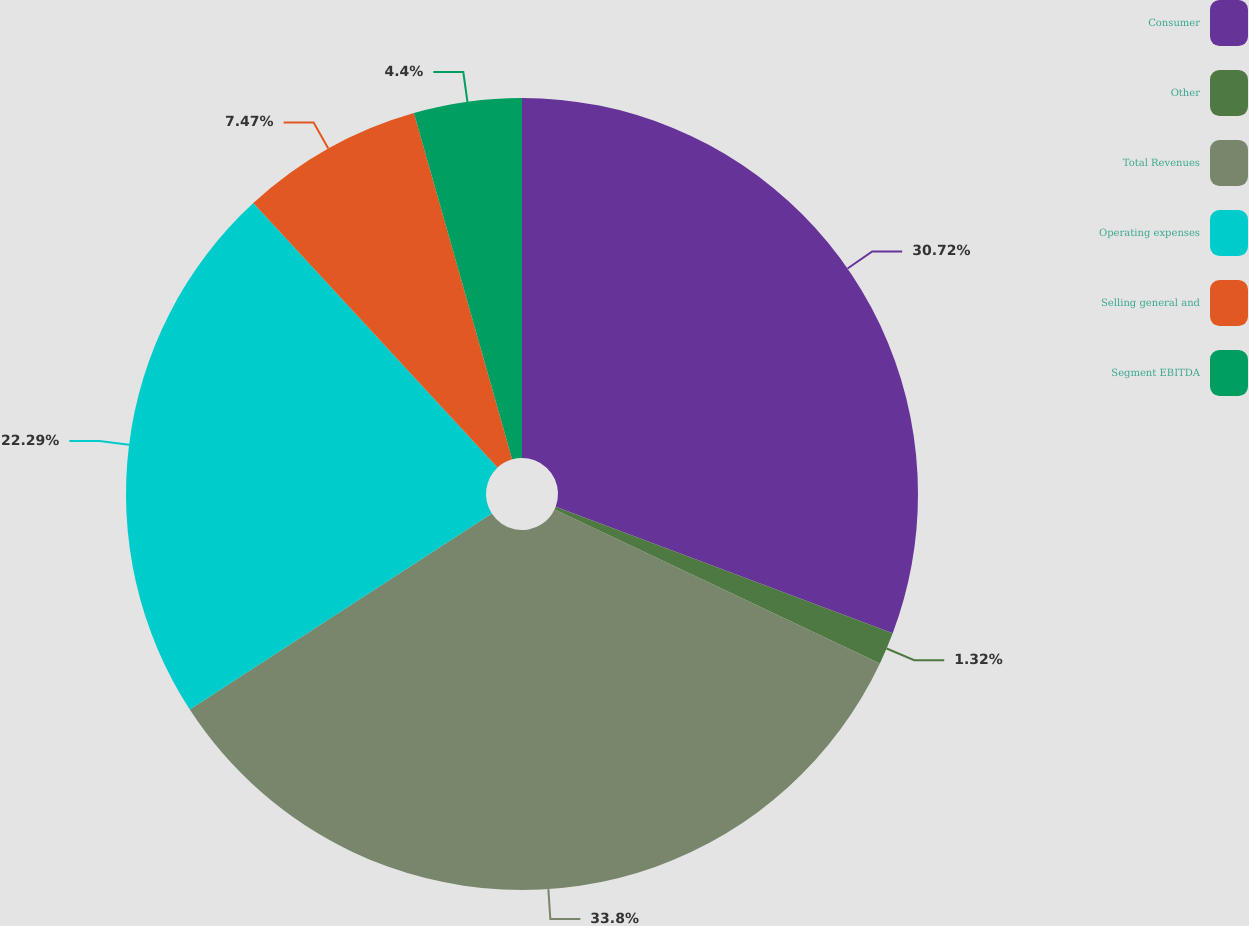Convert chart to OTSL. <chart><loc_0><loc_0><loc_500><loc_500><pie_chart><fcel>Consumer<fcel>Other<fcel>Total Revenues<fcel>Operating expenses<fcel>Selling general and<fcel>Segment EBITDA<nl><fcel>30.72%<fcel>1.32%<fcel>33.8%<fcel>22.29%<fcel>7.47%<fcel>4.4%<nl></chart> 